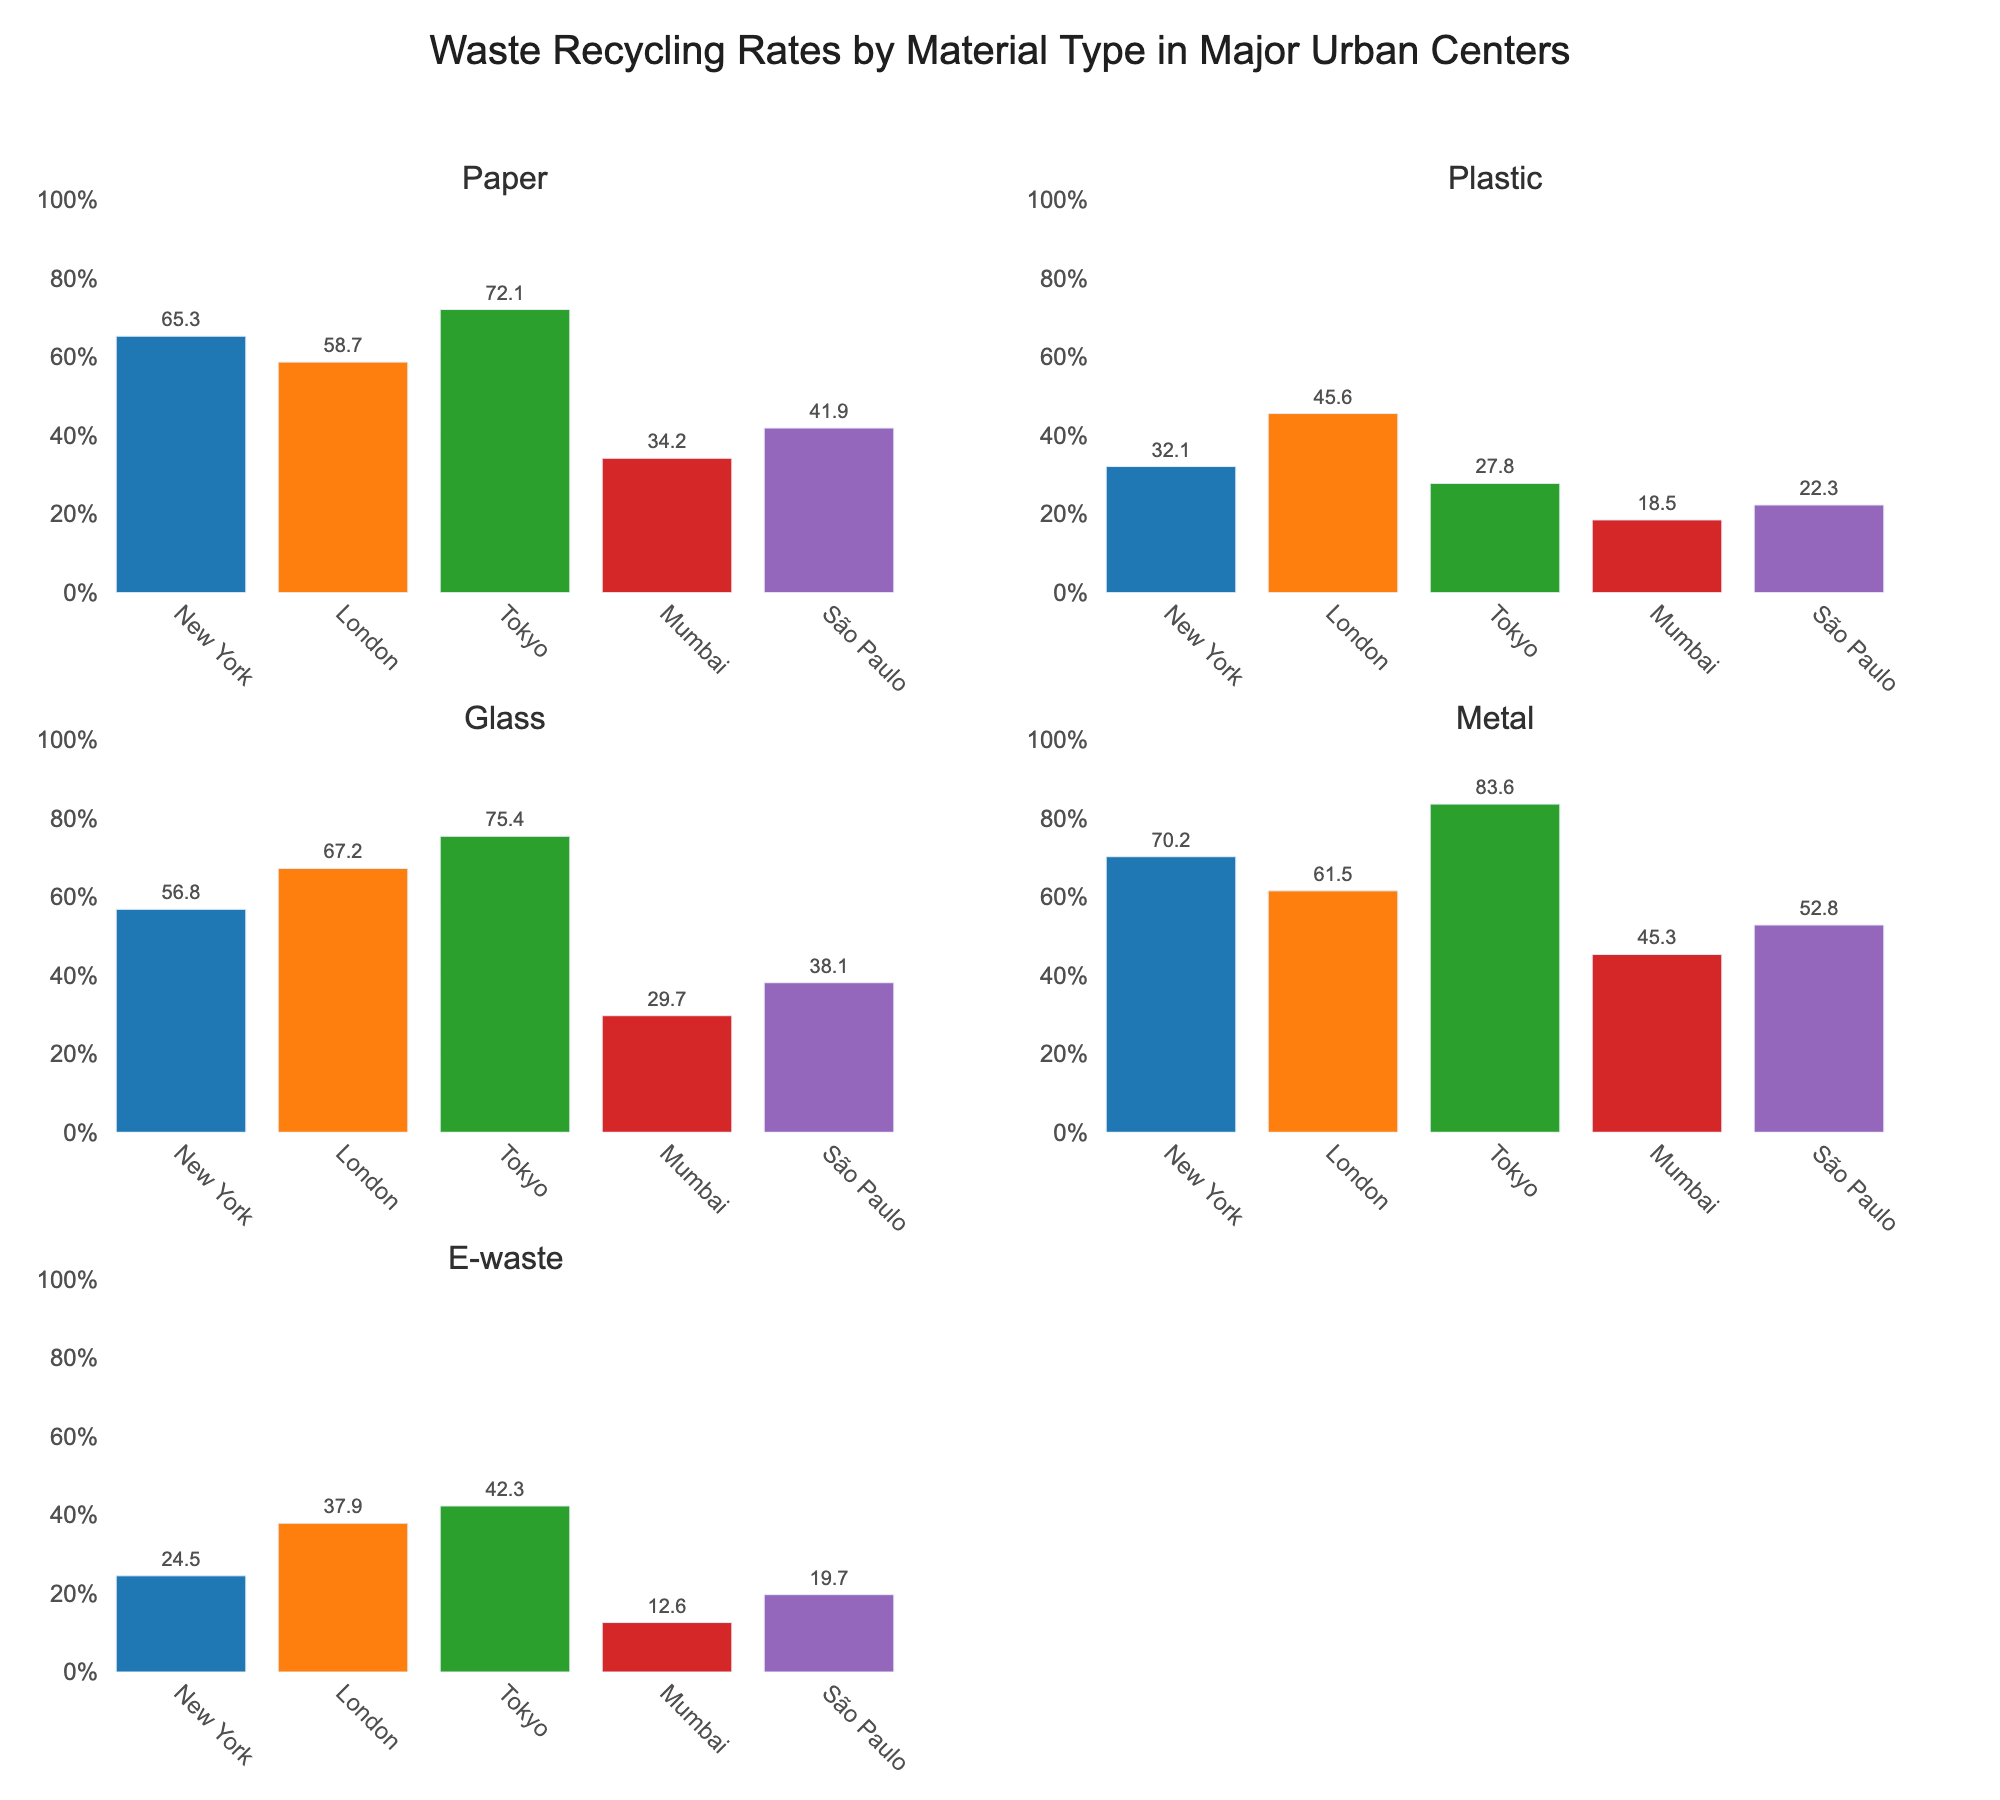Which city has the highest recycling rate for paper? The subplot for paper shows the recycling rates for different cities. The highest bar represents Tokyo with a recycling rate of 72.1%.
Answer: Tokyo What is the range of recycling rates for plastic across the cities? The subplot for plastic shows the recycling rates. The highest value is 45.6% in London, and the lowest is 18.5% in Mumbai. The range is 45.6% - 18.5% = 27.1%.
Answer: 27.1% Which material has the highest average recycling rate across the cities? Calculate the average recycling rate for each material: 
- Paper: (65.3 + 58.7 + 72.1 + 34.2 + 41.9)/5 = 54.44
- Plastic: (32.1 + 45.6 + 27.8 + 18.5 + 22.3)/5 = 29.26
- Glass: (56.8 + 67.2 + 75.4 + 29.7 + 38.1)/5 = 53.44
- Metal: (70.2 + 61.5 + 83.6 + 45.3 + 52.8)/5 = 62.68
- E-waste: (24.5 + 37.9 + 42.3 + 12.6 + 19.7)/5 = 27.4
Metal has the highest average recycling rate of 62.68%.
Answer: Metal How does the recycling rate of plastic in New York compare to Tokyo? The subplot for plastic shows that New York has a recycling rate of 32.1%, while Tokyo has 27.8%. New York's rate is higher than Tokyo's by 32.1% - 27.8% = 4.3%.
Answer: 4.3% higher What is the combined recycling rate for all materials in Mumbai? Sum the recycling rates for Mumbai across all materials:
- Paper: 34.2
- Plastic: 18.5
- Glass: 29.7
- Metal: 45.3
- E-waste: 12.6
Sum = 34.2 + 18.5 + 29.7 + 45.3 + 12.6 = 140.3
The combined recycling rate is 140.3%.
Answer: 140.3% Which city has the lowest recycling rate for e-waste? The subplot for e-waste shows that Mumbai has the lowest recycling rate of 12.6%.
Answer: Mumbai What is the difference in recycling rates for glass between Tokyo and São Paulo? The subplot for glass shows that Tokyo has a recycling rate of 75.4%, while São Paulo has 38.1%. The difference is 75.4% - 38.1% = 37.3%.
Answer: 37.3% Which material has the most consistent recycling rates across the cities (i.e., smallest range)? Calculate the range for each material:
- Paper: 72.1% - 34.2% = 37.9%
- Plastic: 45.6% - 18.5% = 27.1%
- Glass: 75.4% - 29.7% = 45.7%
- Metal: 83.6% - 45.3% = 38.3%
- E-waste: 42.3% - 12.6% = 29.7%
Plastic has the smallest range of 27.1%, indicating the most consistent recycling rates.
Answer: Plastic 